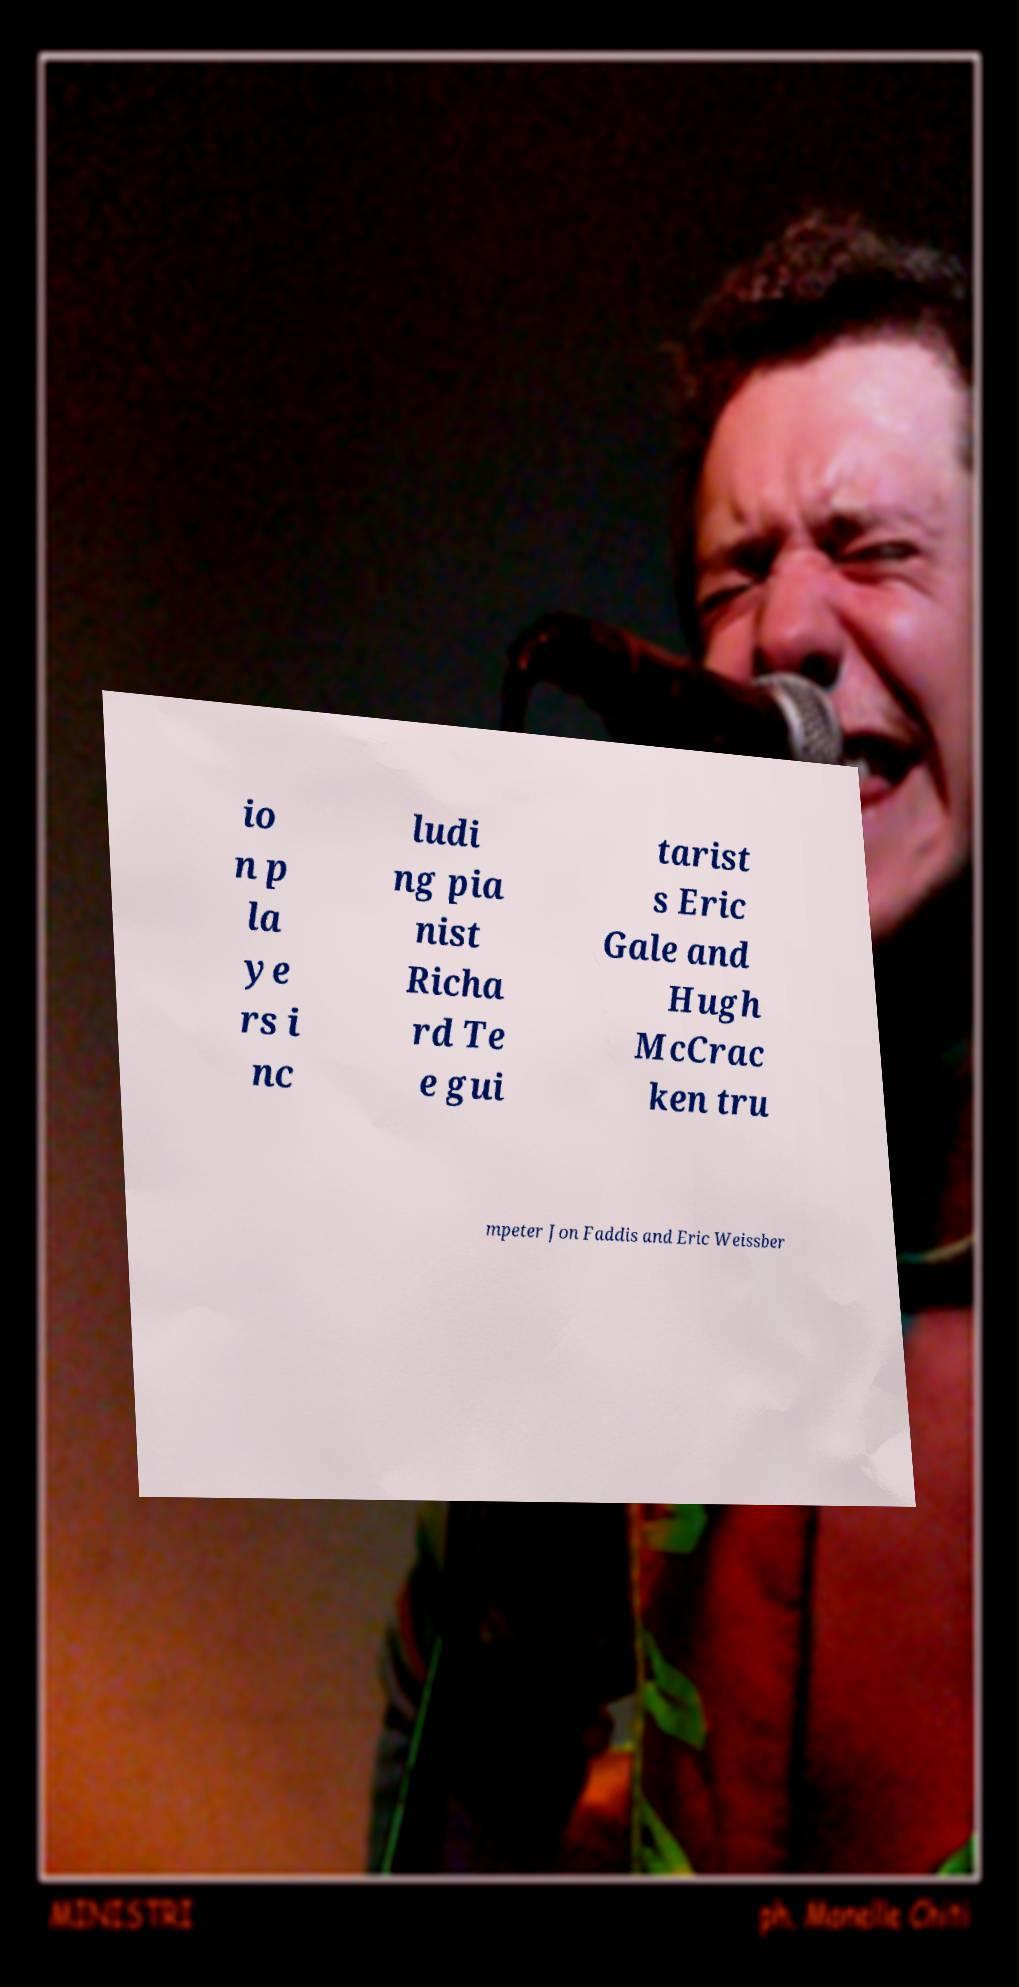Can you accurately transcribe the text from the provided image for me? io n p la ye rs i nc ludi ng pia nist Richa rd Te e gui tarist s Eric Gale and Hugh McCrac ken tru mpeter Jon Faddis and Eric Weissber 